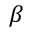Convert formula to latex. <formula><loc_0><loc_0><loc_500><loc_500>\beta</formula> 